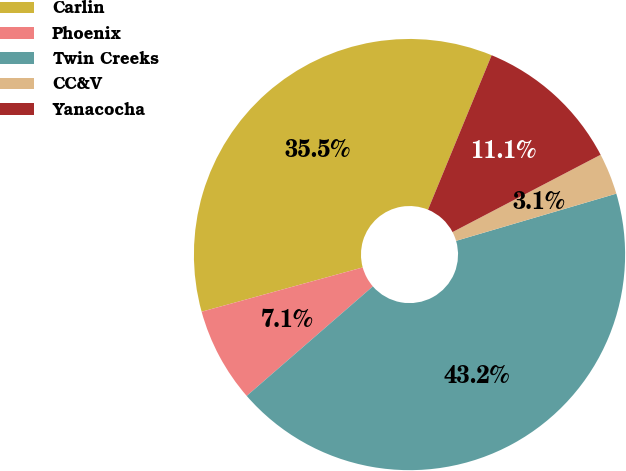Convert chart. <chart><loc_0><loc_0><loc_500><loc_500><pie_chart><fcel>Carlin<fcel>Phoenix<fcel>Twin Creeks<fcel>CC&V<fcel>Yanacocha<nl><fcel>35.49%<fcel>7.11%<fcel>43.18%<fcel>3.1%<fcel>11.12%<nl></chart> 